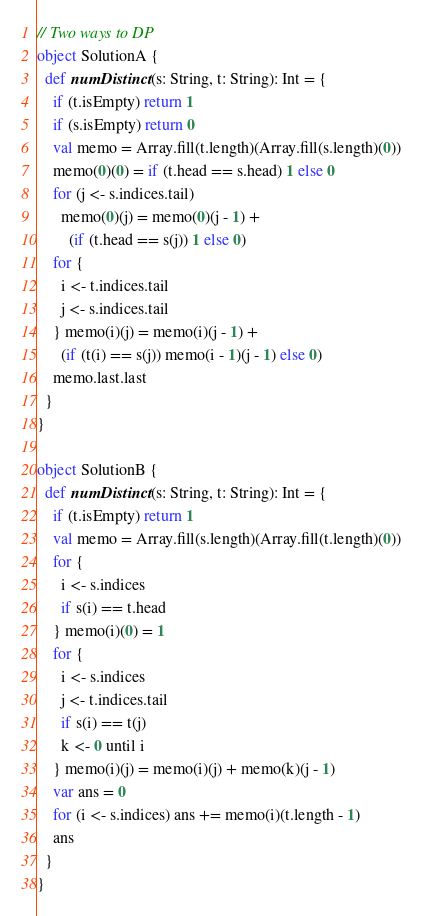<code> <loc_0><loc_0><loc_500><loc_500><_Scala_>// Two ways to DP
object SolutionA {
  def numDistinct(s: String, t: String): Int = {
    if (t.isEmpty) return 1
    if (s.isEmpty) return 0
    val memo = Array.fill(t.length)(Array.fill(s.length)(0))
    memo(0)(0) = if (t.head == s.head) 1 else 0
    for (j <- s.indices.tail)
      memo(0)(j) = memo(0)(j - 1) +
        (if (t.head == s(j)) 1 else 0)
    for {
      i <- t.indices.tail
      j <- s.indices.tail
    } memo(i)(j) = memo(i)(j - 1) +
      (if (t(i) == s(j)) memo(i - 1)(j - 1) else 0)
    memo.last.last
  }
}

object SolutionB {
  def numDistinct(s: String, t: String): Int = {
    if (t.isEmpty) return 1
    val memo = Array.fill(s.length)(Array.fill(t.length)(0))
    for {
      i <- s.indices
      if s(i) == t.head
    } memo(i)(0) = 1
    for {
      i <- s.indices
      j <- t.indices.tail
      if s(i) == t(j)
      k <- 0 until i
    } memo(i)(j) = memo(i)(j) + memo(k)(j - 1)
    var ans = 0
    for (i <- s.indices) ans += memo(i)(t.length - 1)
    ans
  }
}</code> 